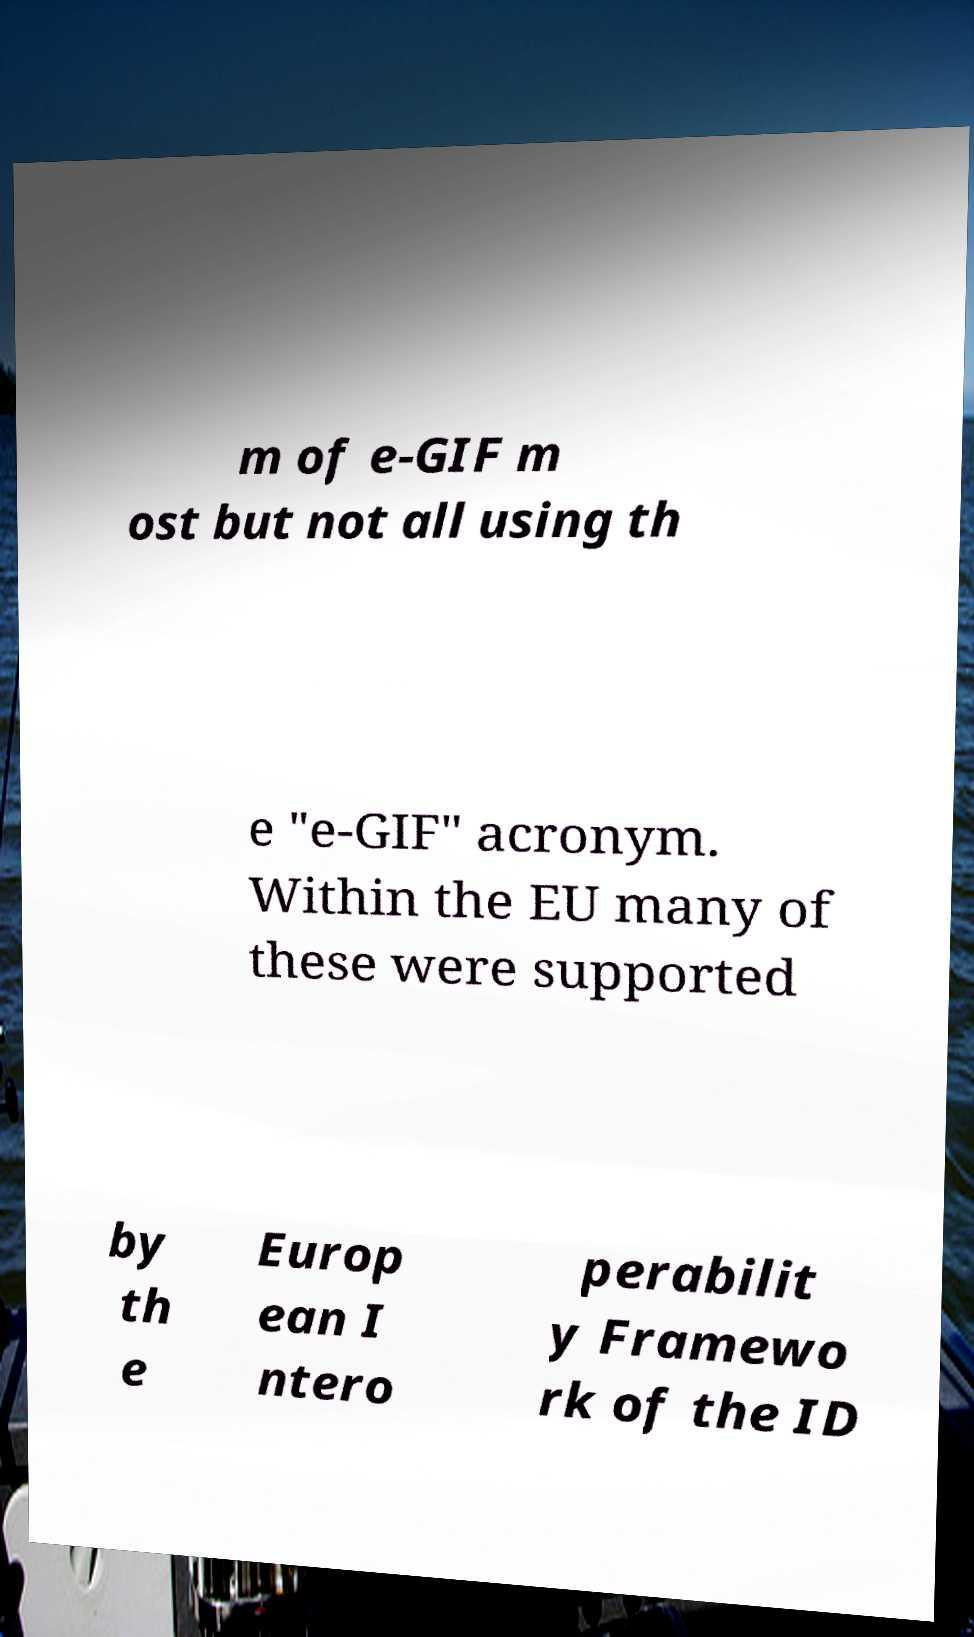I need the written content from this picture converted into text. Can you do that? m of e-GIF m ost but not all using th e "e-GIF" acronym. Within the EU many of these were supported by th e Europ ean I ntero perabilit y Framewo rk of the ID 